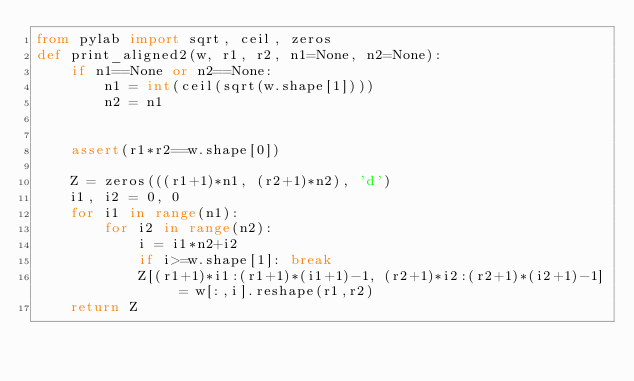Convert code to text. <code><loc_0><loc_0><loc_500><loc_500><_Python_>from pylab import sqrt, ceil, zeros
def print_aligned2(w, r1, r2, n1=None, n2=None):
    if n1==None or n2==None:
        n1 = int(ceil(sqrt(w.shape[1])))
        n2 = n1
        

    assert(r1*r2==w.shape[0])

    Z = zeros(((r1+1)*n1, (r2+1)*n2), 'd')
    i1, i2 = 0, 0
    for i1 in range(n1):
        for i2 in range(n2):
            i = i1*n2+i2
            if i>=w.shape[1]: break
            Z[(r1+1)*i1:(r1+1)*(i1+1)-1, (r2+1)*i2:(r2+1)*(i2+1)-1] = w[:,i].reshape(r1,r2)
    return Z
</code> 